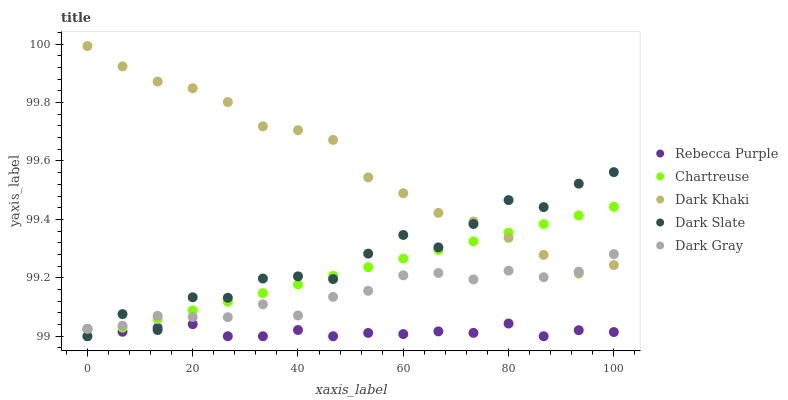Does Rebecca Purple have the minimum area under the curve?
Answer yes or no. Yes. Does Dark Khaki have the maximum area under the curve?
Answer yes or no. Yes. Does Dark Slate have the minimum area under the curve?
Answer yes or no. No. Does Dark Slate have the maximum area under the curve?
Answer yes or no. No. Is Chartreuse the smoothest?
Answer yes or no. Yes. Is Dark Slate the roughest?
Answer yes or no. Yes. Is Dark Slate the smoothest?
Answer yes or no. No. Is Chartreuse the roughest?
Answer yes or no. No. Does Dark Slate have the lowest value?
Answer yes or no. Yes. Does Dark Gray have the lowest value?
Answer yes or no. No. Does Dark Khaki have the highest value?
Answer yes or no. Yes. Does Dark Slate have the highest value?
Answer yes or no. No. Is Rebecca Purple less than Dark Khaki?
Answer yes or no. Yes. Is Dark Khaki greater than Rebecca Purple?
Answer yes or no. Yes. Does Dark Slate intersect Rebecca Purple?
Answer yes or no. Yes. Is Dark Slate less than Rebecca Purple?
Answer yes or no. No. Is Dark Slate greater than Rebecca Purple?
Answer yes or no. No. Does Rebecca Purple intersect Dark Khaki?
Answer yes or no. No. 